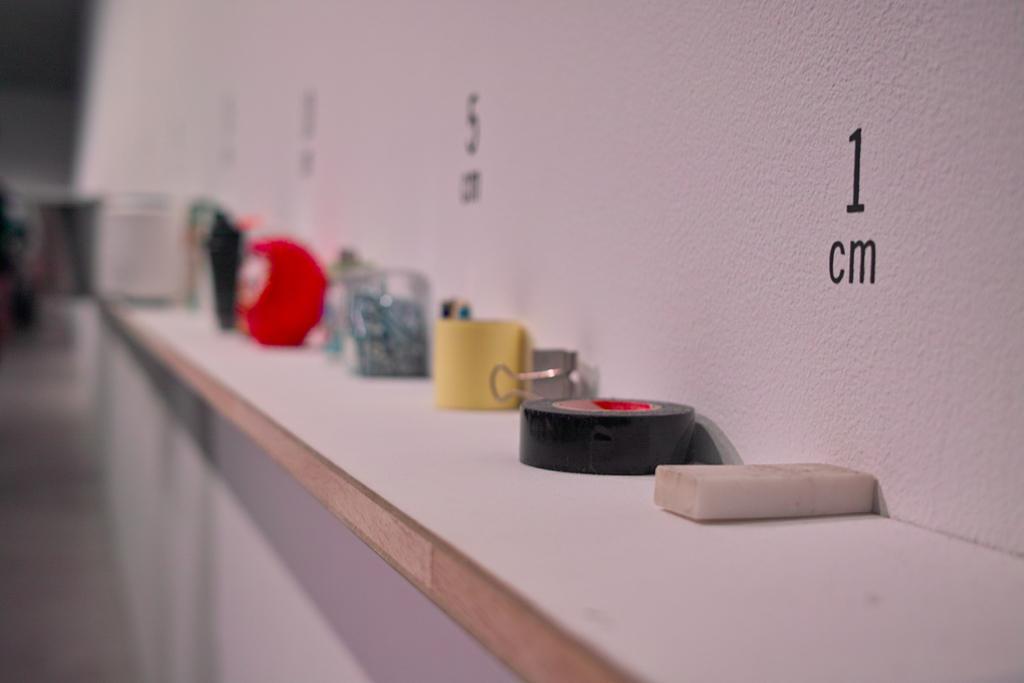Could you give a brief overview of what you see in this image? In this picture we can observe some accessories placed on the desk which is in white color. We can observe a wall which is in white color. There are numbers painted on this wall. The background is completely blurred. 